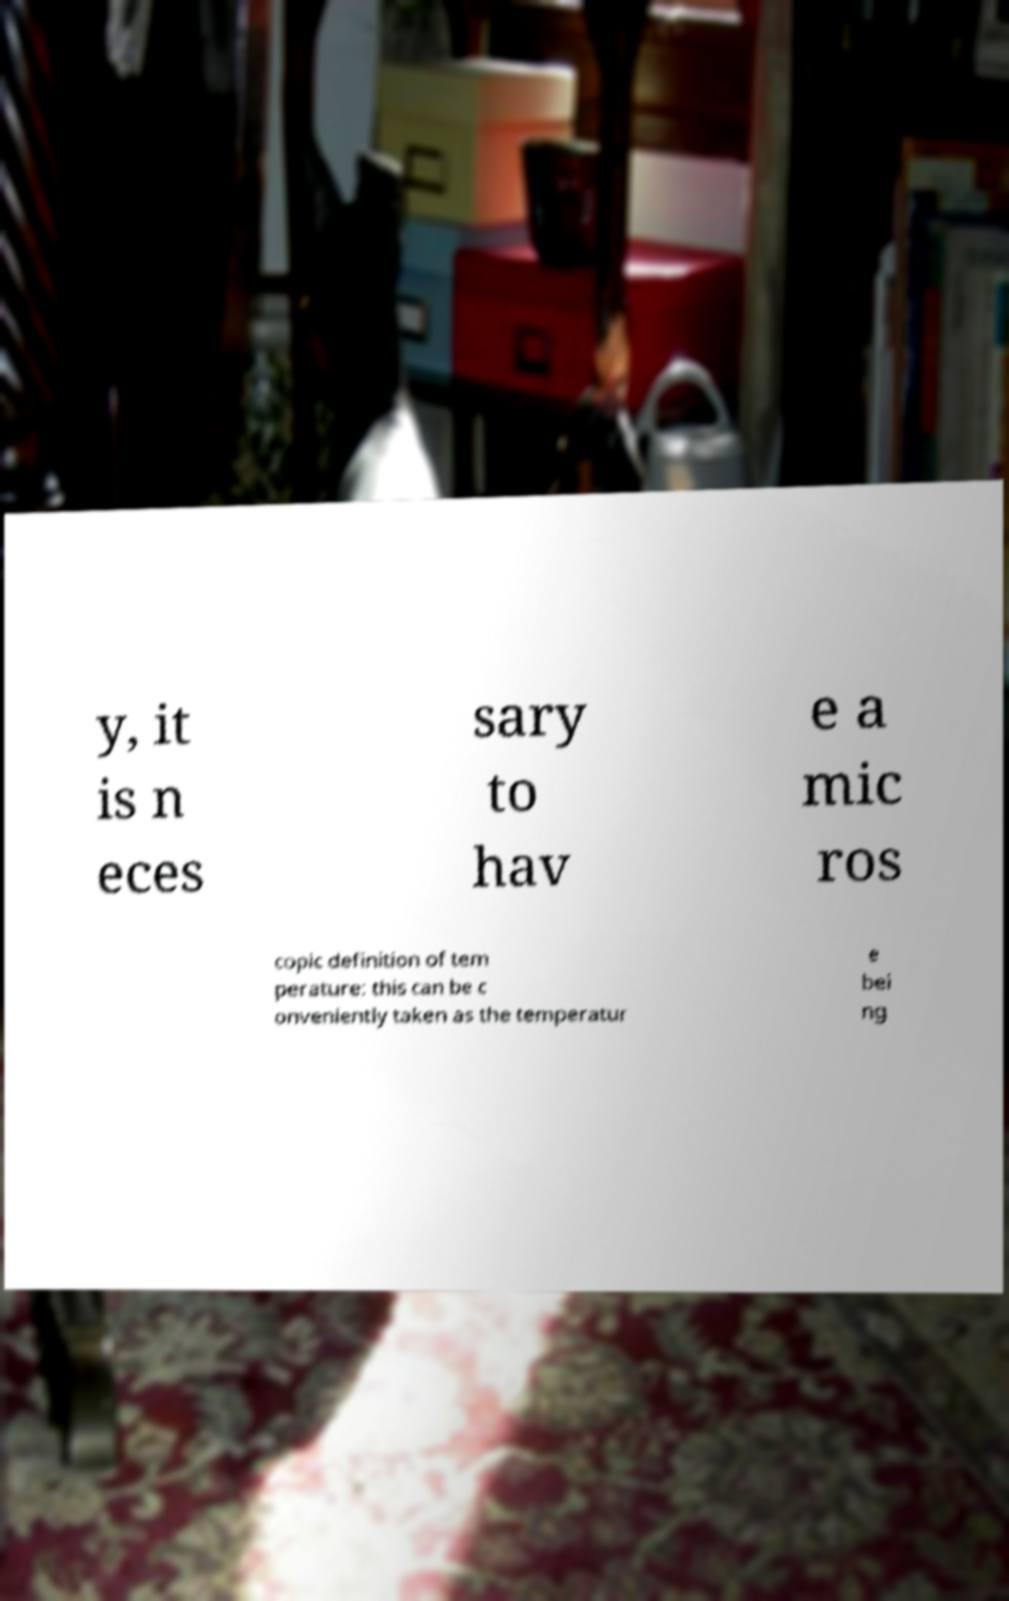I need the written content from this picture converted into text. Can you do that? y, it is n eces sary to hav e a mic ros copic definition of tem perature: this can be c onveniently taken as the temperatur e bei ng 